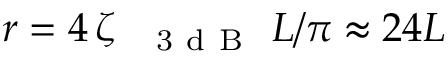Convert formula to latex. <formula><loc_0><loc_0><loc_500><loc_500>r = 4 \, \zeta _ { \text  subscript { 3 d B } } L / \pi \approx 2 4 L</formula> 